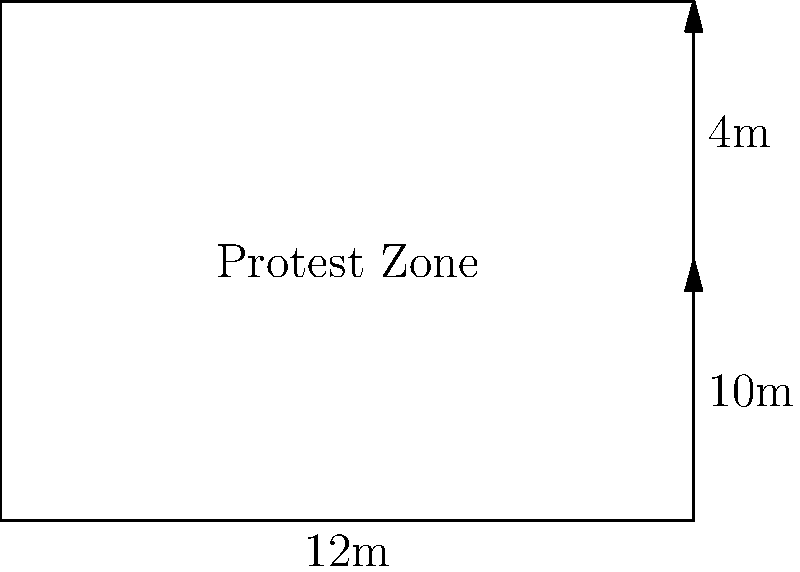A rectangular protest zone is designated outside a stadium. The zone measures 12 meters in width and has a total area of 144 square meters. Using vector operations, calculate the length of the protest zone and express the area as the magnitude of a cross product between two vectors representing the width and length of the zone. Let's approach this step-by-step:

1) First, we need to find the length of the protest zone. We know:
   - Width = 12 meters
   - Area = 144 square meters

   Using the area formula for a rectangle: Area = Width × Length
   144 = 12 × Length
   Length = 144 ÷ 12 = 12 meters

2) Now, let's define our vectors:
   - Vector $\mathbf{a}$ represents the width: $\mathbf{a} = 12\mathbf{i}$
   - Vector $\mathbf{b}$ represents the length: $\mathbf{b} = 12\mathbf{j}$

3) The area can be expressed as the magnitude of the cross product of these vectors:
   Area = $|\mathbf{a} \times \mathbf{b}|$

4) Calculate the cross product:
   $\mathbf{a} \times \mathbf{b} = (12\mathbf{i}) \times (12\mathbf{j}) = 144\mathbf{k}$

5) The magnitude of this cross product is:
   $|\mathbf{a} \times \mathbf{b}| = |144\mathbf{k}| = 144$

This confirms that the area calculated using vector operations matches the given area.
Answer: Length: 12m; Area: $|\mathbf{a} \times \mathbf{b}| = 144$ sq m 